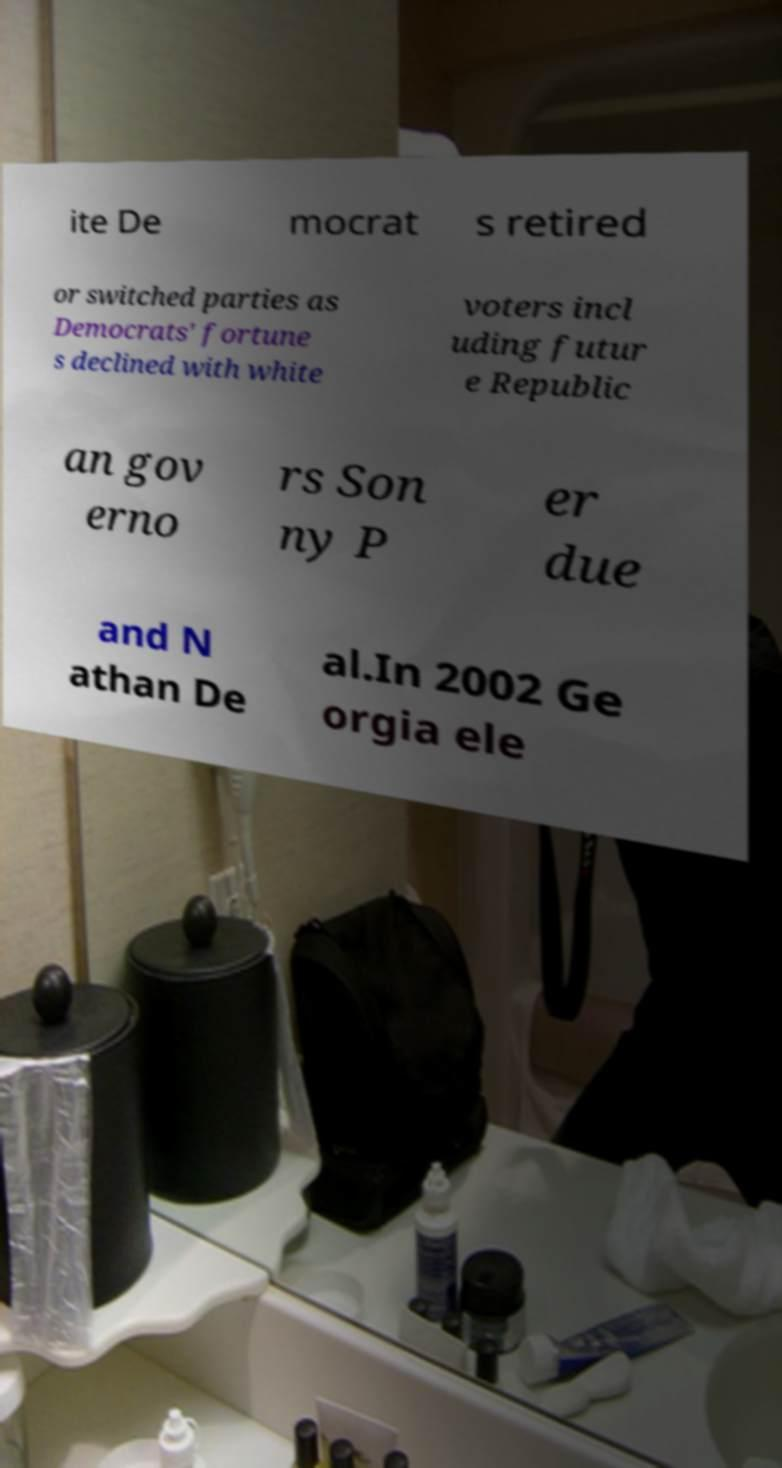What messages or text are displayed in this image? I need them in a readable, typed format. ite De mocrat s retired or switched parties as Democrats' fortune s declined with white voters incl uding futur e Republic an gov erno rs Son ny P er due and N athan De al.In 2002 Ge orgia ele 